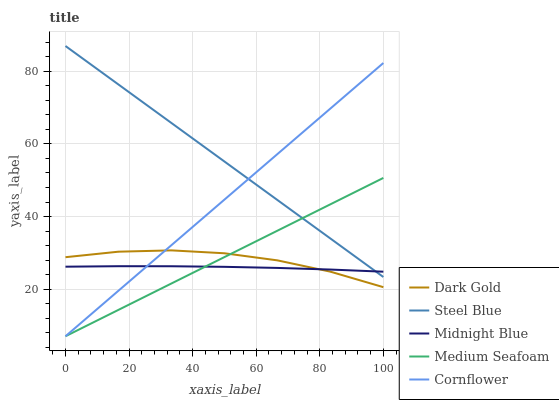Does Midnight Blue have the minimum area under the curve?
Answer yes or no. Yes. Does Steel Blue have the maximum area under the curve?
Answer yes or no. Yes. Does Medium Seafoam have the minimum area under the curve?
Answer yes or no. No. Does Medium Seafoam have the maximum area under the curve?
Answer yes or no. No. Is Cornflower the smoothest?
Answer yes or no. Yes. Is Dark Gold the roughest?
Answer yes or no. Yes. Is Medium Seafoam the smoothest?
Answer yes or no. No. Is Medium Seafoam the roughest?
Answer yes or no. No. Does Cornflower have the lowest value?
Answer yes or no. Yes. Does Midnight Blue have the lowest value?
Answer yes or no. No. Does Steel Blue have the highest value?
Answer yes or no. Yes. Does Medium Seafoam have the highest value?
Answer yes or no. No. Is Dark Gold less than Steel Blue?
Answer yes or no. Yes. Is Steel Blue greater than Dark Gold?
Answer yes or no. Yes. Does Cornflower intersect Midnight Blue?
Answer yes or no. Yes. Is Cornflower less than Midnight Blue?
Answer yes or no. No. Is Cornflower greater than Midnight Blue?
Answer yes or no. No. Does Dark Gold intersect Steel Blue?
Answer yes or no. No. 